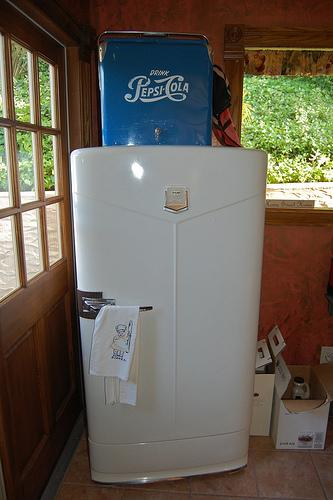Describe the appearance of the window and door in the image. The window has a wooden frame with glass panes, and the brown door has many window panes. Discuss the material of the refrigerator door handle. The door handle is made of silver metal. What does the pepsi cola container look like? The container is blue with a white cursive Pepsi Cola logo, a long silver handle, and a spout. Which objects are located on the floor? Boxes, a white cardboard box, beige tiles, and cardboard boxes near the refrigerator. List the items found in the image that are placed on the fridge. Blue Pepsi Cola box, white hand towel with a person on it, and red and black clothing. What kind of floor does the room have? The floor has beige or tan-colored tiles. Explain the appearance of the fridge and its handle. The fridge is an old-style white refrigerator with a silver handle. Mention the objects related to the white hand towel. The towel is on the door handle, has a cartoon image, and is described as a dish towel. Are there any objects placed outside the building? If so, list them. There are plants with leaves and sand outside the building. Describe the objects found within the open box. There is a brown sauce bottle with a black cap and a white spout inside the box. 